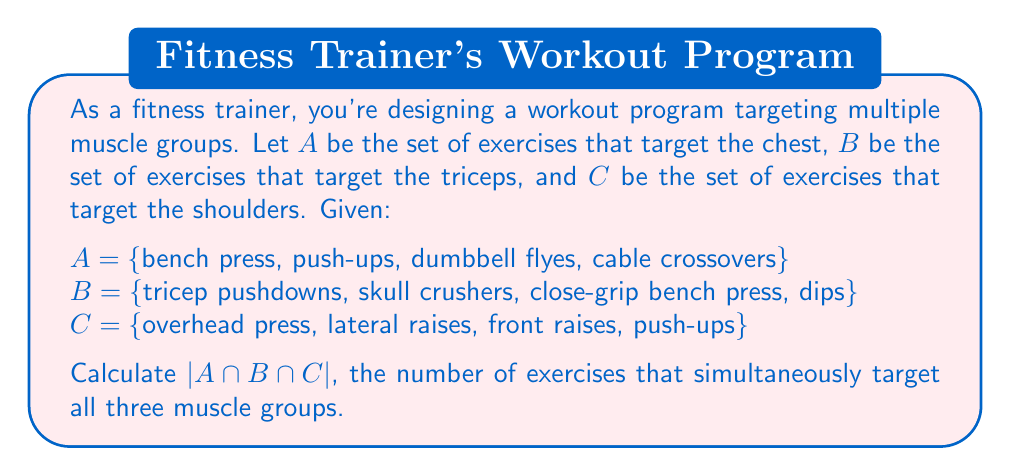Solve this math problem. To solve this problem, we need to find the intersection of all three sets and then determine its cardinality. Let's approach this step-by-step:

1. First, let's identify the elements that appear in all three sets:

   A = {bench press, push-ups, dumbbell flyes, cable crossovers}
   B = {tricep pushdowns, skull crushers, close-grip bench press, dips}
   C = {overhead press, lateral raises, front raises, push-ups}

2. We can see that "push-ups" is the only exercise that appears in both sets A and C.

3. Now, we need to check if "push-ups" also appears in set B. It does not.

4. Therefore, the intersection of all three sets is an empty set:

   $A \cap B \cap C = \emptyset$

5. The cardinality of an empty set is always 0:

   $|A \cap B \cap C| = |\emptyset| = 0$

This result indicates that there are no exercises in the given lists that simultaneously target all three muscle groups (chest, triceps, and shoulders) according to the provided information.
Answer: $|A \cap B \cap C| = 0$ 